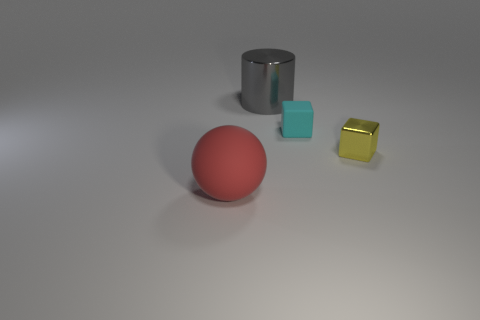There is a red object that is the same size as the gray shiny thing; what is it made of?
Make the answer very short. Rubber. Do the object that is on the left side of the large gray object and the shiny thing behind the yellow metal cube have the same size?
Your answer should be very brief. Yes. What number of things are either tiny blue objects or objects that are to the left of the yellow shiny object?
Offer a terse response. 3. Is there a cyan object of the same shape as the yellow metal object?
Ensure brevity in your answer.  Yes. There is a matte object that is right of the rubber thing that is in front of the cyan rubber thing; what is its size?
Make the answer very short. Small. Does the tiny metal object have the same color as the matte sphere?
Give a very brief answer. No. How many metallic things are either big gray balls or big cylinders?
Provide a short and direct response. 1. How many small blue metallic blocks are there?
Your answer should be very brief. 0. Are the tiny object behind the small yellow shiny block and the large thing behind the small yellow cube made of the same material?
Provide a succinct answer. No. What color is the other metal thing that is the same shape as the cyan thing?
Your answer should be compact. Yellow. 